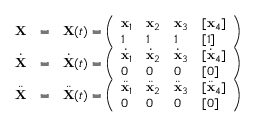<formula> <loc_0><loc_0><loc_500><loc_500>\begin{array} { r l r } { \mathbf X } & { = } & { { \mathbf X } ( t ) = \left ( \begin{array} { l l l l } { { \mathbf x } _ { 1 } } & { { \mathbf x } _ { 2 } } & { { \mathbf x } _ { 3 } } & { [ { \mathbf x } _ { 4 } ] } \\ { 1 } & { 1 } & { 1 } & { [ 1 ] } \end{array} \right ) } \\ { \dot { \mathbf X } } & { = } & { \dot { \mathbf X } ( t ) = \left ( \begin{array} { l l l l } { \dot { \mathbf x } _ { 1 } } & { \dot { \mathbf x } _ { 2 } } & { \dot { \mathbf x } _ { 3 } } & { [ \dot { \mathbf x } _ { 4 } ] } \\ { 0 } & { 0 } & { 0 } & { [ 0 ] } \end{array} \right ) } \\ { \ddot { \mathbf X } } & { = } & { \ddot { \mathbf X } ( t ) = \left ( \begin{array} { l l l l } { \ddot { \mathbf x } _ { 1 } } & { \ddot { \mathbf x } _ { 2 } } & { \ddot { \mathbf x } _ { 3 } } & { [ \ddot { \mathbf x } _ { 4 } ] } \\ { 0 } & { 0 } & { 0 } & { [ 0 ] } \end{array} \right ) } \end{array}</formula> 